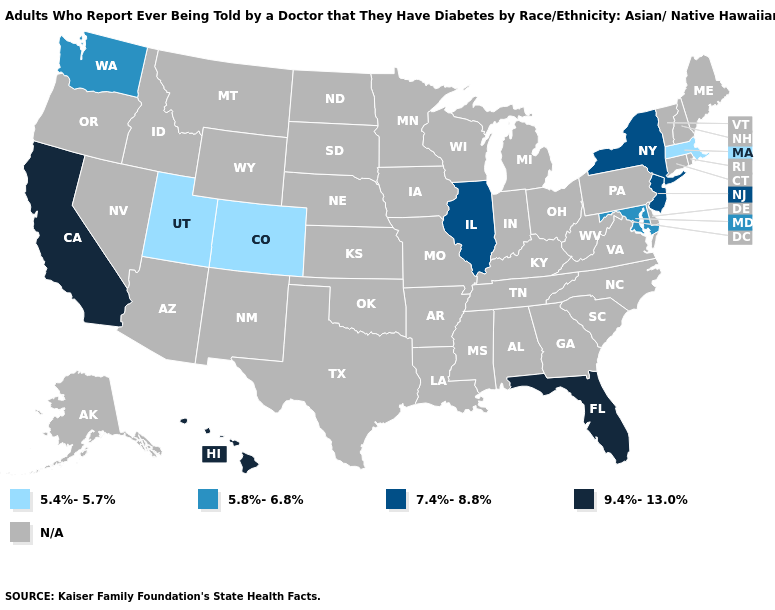What is the value of North Carolina?
Keep it brief. N/A. Does New York have the highest value in the Northeast?
Write a very short answer. Yes. Name the states that have a value in the range N/A?
Short answer required. Alabama, Alaska, Arizona, Arkansas, Connecticut, Delaware, Georgia, Idaho, Indiana, Iowa, Kansas, Kentucky, Louisiana, Maine, Michigan, Minnesota, Mississippi, Missouri, Montana, Nebraska, Nevada, New Hampshire, New Mexico, North Carolina, North Dakota, Ohio, Oklahoma, Oregon, Pennsylvania, Rhode Island, South Carolina, South Dakota, Tennessee, Texas, Vermont, Virginia, West Virginia, Wisconsin, Wyoming. What is the value of Arkansas?
Quick response, please. N/A. Name the states that have a value in the range 7.4%-8.8%?
Be succinct. Illinois, New Jersey, New York. What is the highest value in the USA?
Concise answer only. 9.4%-13.0%. Name the states that have a value in the range 5.4%-5.7%?
Concise answer only. Colorado, Massachusetts, Utah. Which states have the lowest value in the West?
Quick response, please. Colorado, Utah. Name the states that have a value in the range N/A?
Answer briefly. Alabama, Alaska, Arizona, Arkansas, Connecticut, Delaware, Georgia, Idaho, Indiana, Iowa, Kansas, Kentucky, Louisiana, Maine, Michigan, Minnesota, Mississippi, Missouri, Montana, Nebraska, Nevada, New Hampshire, New Mexico, North Carolina, North Dakota, Ohio, Oklahoma, Oregon, Pennsylvania, Rhode Island, South Carolina, South Dakota, Tennessee, Texas, Vermont, Virginia, West Virginia, Wisconsin, Wyoming. Name the states that have a value in the range 5.4%-5.7%?
Short answer required. Colorado, Massachusetts, Utah. What is the value of New Jersey?
Answer briefly. 7.4%-8.8%. Does Massachusetts have the lowest value in the USA?
Quick response, please. Yes. Which states have the lowest value in the USA?
Answer briefly. Colorado, Massachusetts, Utah. Name the states that have a value in the range 5.8%-6.8%?
Be succinct. Maryland, Washington. Among the states that border Wisconsin , which have the highest value?
Short answer required. Illinois. 